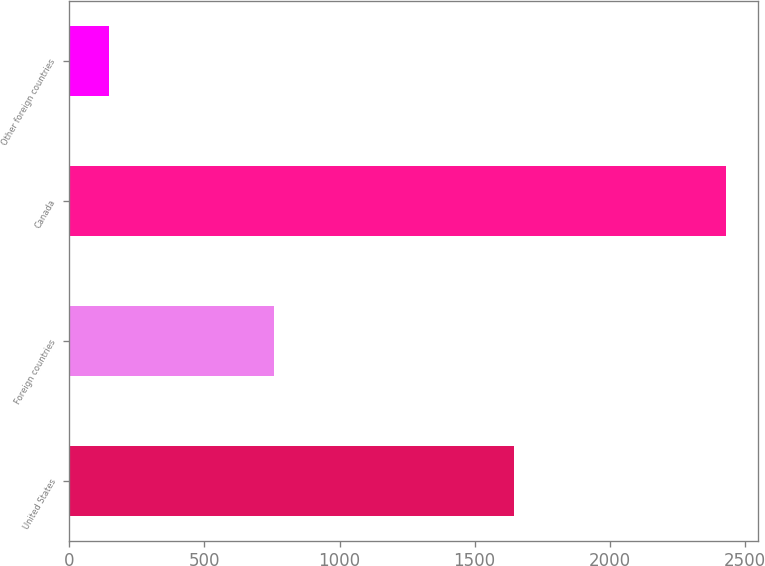Convert chart to OTSL. <chart><loc_0><loc_0><loc_500><loc_500><bar_chart><fcel>United States<fcel>Foreign countries<fcel>Canada<fcel>Other foreign countries<nl><fcel>1646<fcel>759<fcel>2429<fcel>148<nl></chart> 